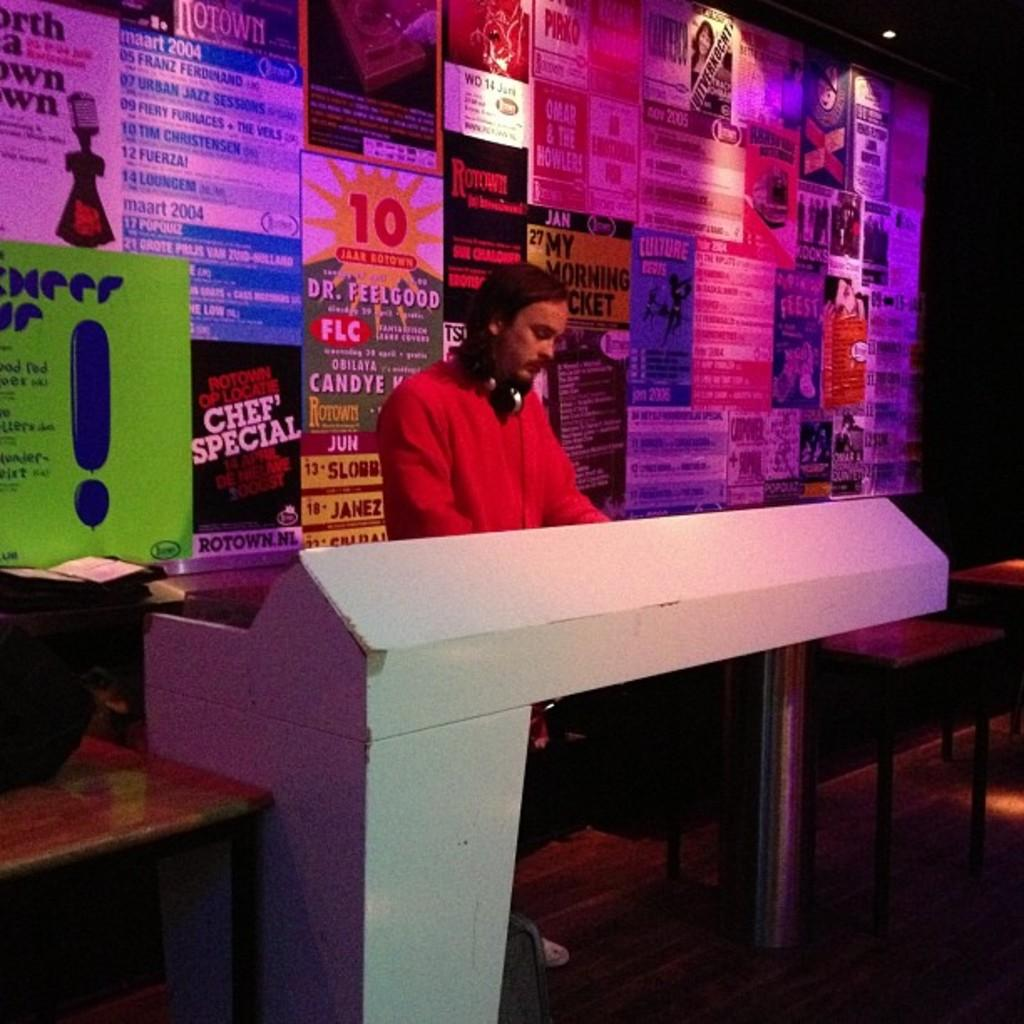<image>
Provide a brief description of the given image. a chef special advertisement with a man in front of it 